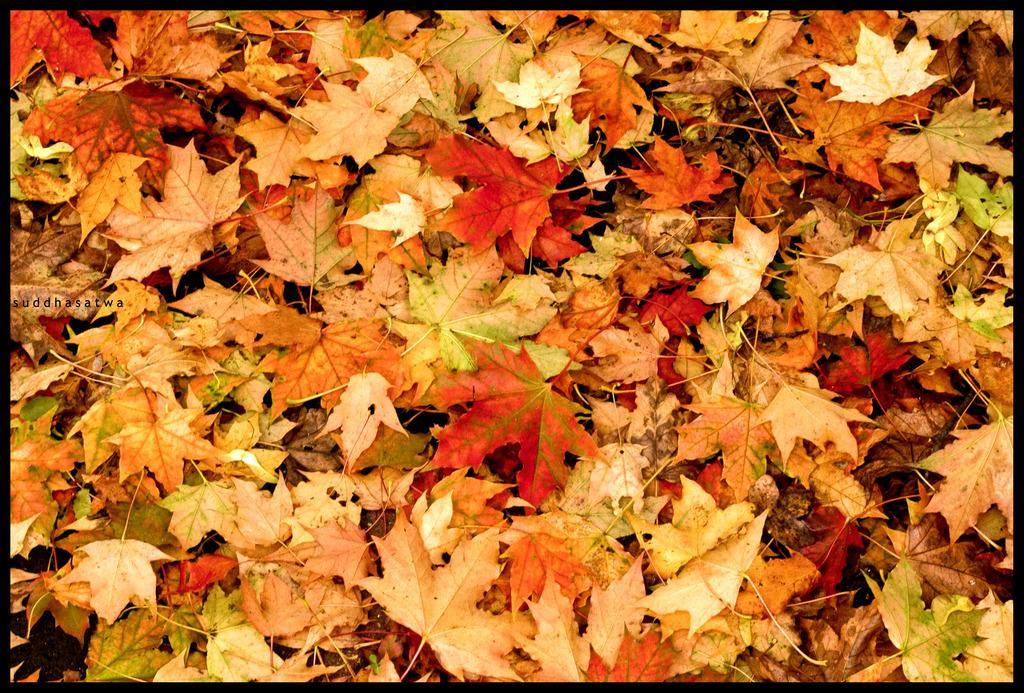Could you give a brief overview of what you see in this image? In this picture there are few leaves which are in orange color. 